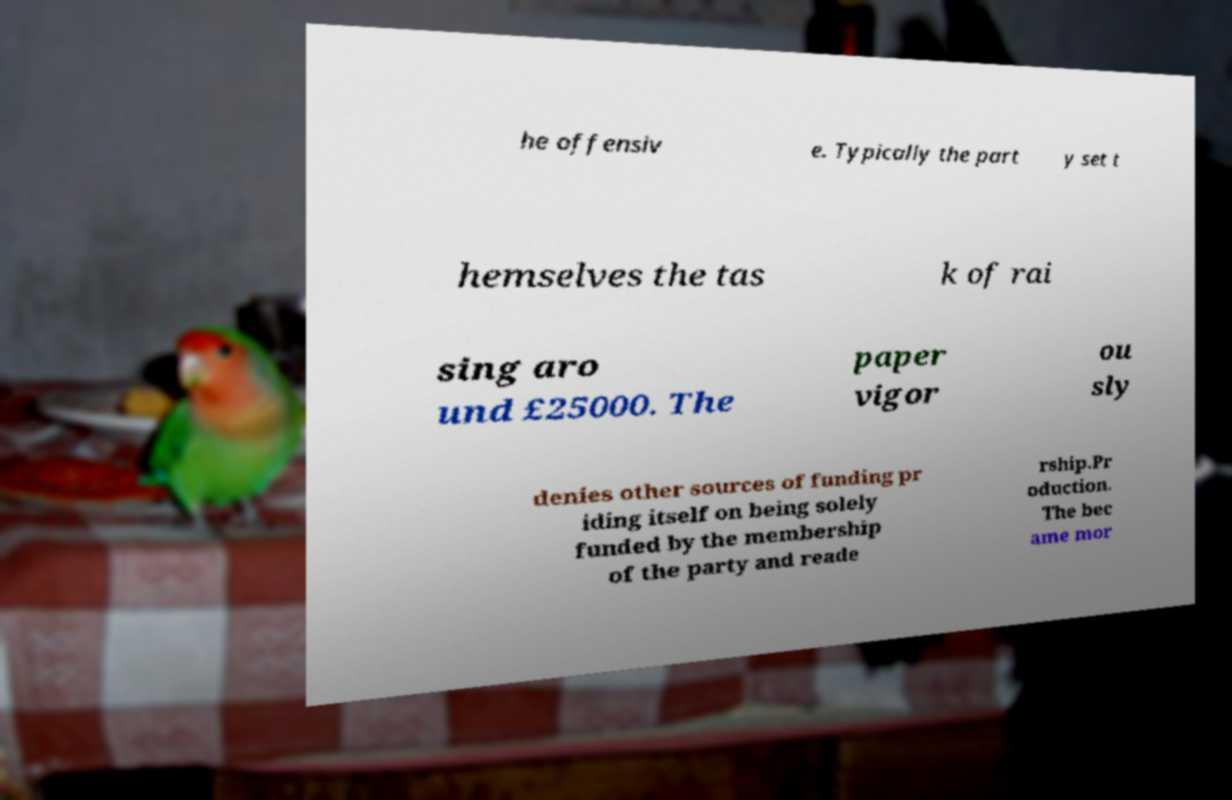For documentation purposes, I need the text within this image transcribed. Could you provide that? he offensiv e. Typically the part y set t hemselves the tas k of rai sing aro und £25000. The paper vigor ou sly denies other sources of funding pr iding itself on being solely funded by the membership of the party and reade rship.Pr oduction. The bec ame mor 